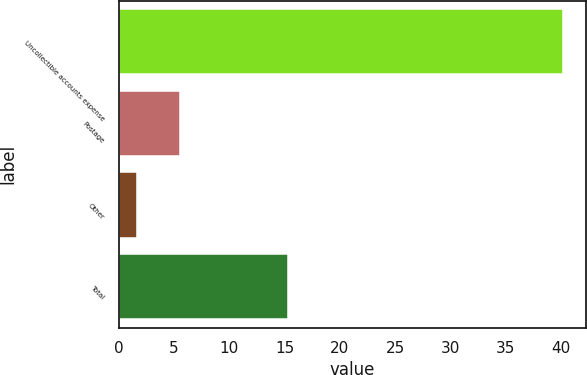Convert chart. <chart><loc_0><loc_0><loc_500><loc_500><bar_chart><fcel>Uncollectible accounts expense<fcel>Postage<fcel>Other<fcel>Total<nl><fcel>40.2<fcel>5.55<fcel>1.7<fcel>15.3<nl></chart> 